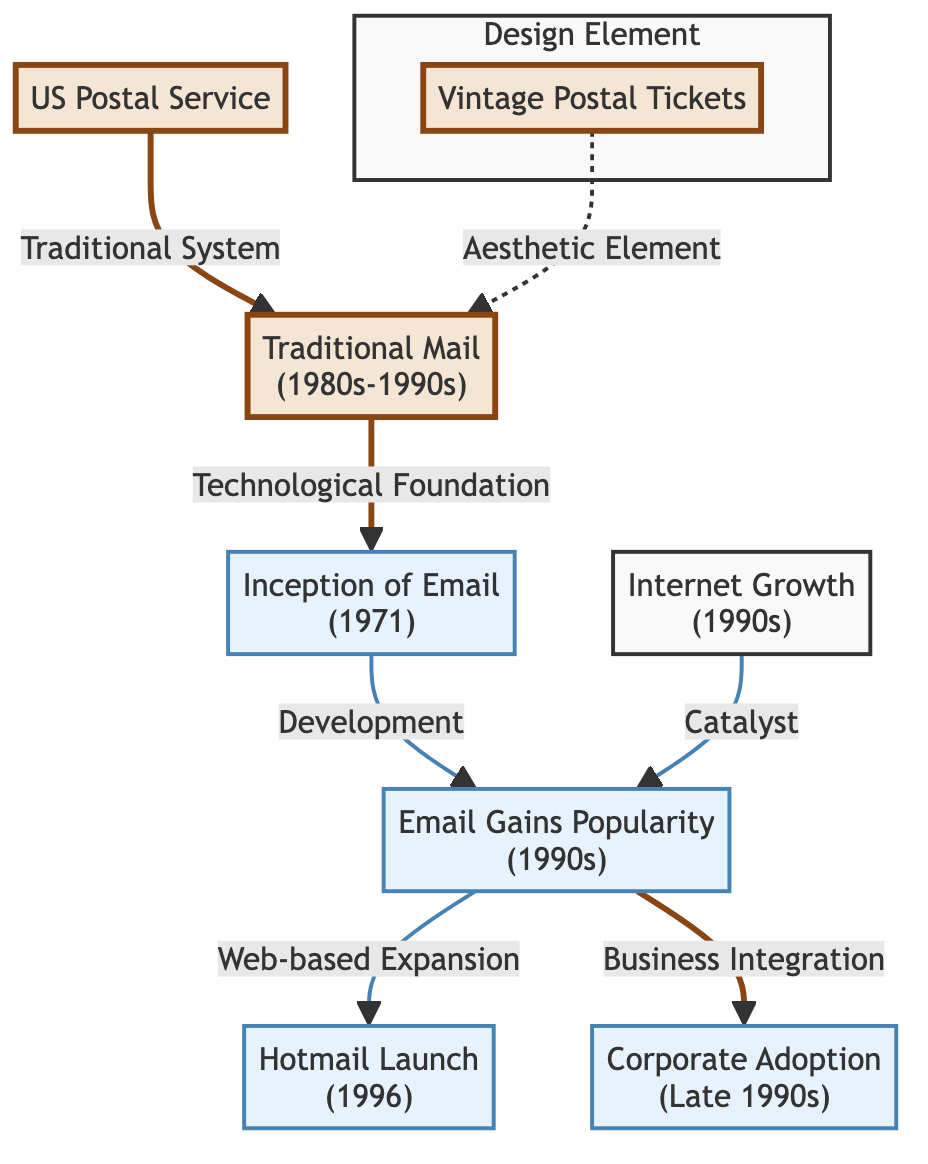What is the first event shown in the diagram? The first event is identified as "Inception of Email" which occurred in 1971. It is the starting point of the sequence related to email, linking it to traditional mail.
Answer: Inception of Email (1971) How many main events are depicted in the diagram? The main events represented in the diagram include: "Traditional Mail," "Inception of Email," "Email Gains Popularity," "Hotmail Launch," and "Corporate Adoption." Thus, there are five main events.
Answer: 5 What is the relationship between "Email Gains Popularity" and "Corporate Adoption"? The relationship is that "Email Gains Popularity" serves as a precursor to "Corporate Adoption." As email gains more usage and recognition, it leads to its adoption in the corporate sector, particularly toward the late 1990s.
Answer: Precursor Which aesthetic element is connected to "Traditional Mail"? The aesthetic element is "Vintage Postal Tickets," which is connected to "Traditional Mail" through the design influence represented by lines in the diagram.
Answer: Vintage Postal Tickets What major technological factor led to the popularity of email in the 1990s? The major technological factor is "Internet Growth," which is shown as a catalyst leading to the rising popularity of email during that decade.
Answer: Internet Growth Which email service was launched in 1996 according to the diagram? The email service launched in 1996 according to the diagram is "Hotmail." It is noted as a significant milestone in the web-based expansion of email usage.
Answer: Hotmail What does the arrow pointing from "Internet Growth" to "Email Gains Popularity" signify? The arrow signifies that "Internet Growth" acts as a catalyst that directly contributes to the increase in popularity of email during the 1990s.
Answer: Catalyst What type of design inspiration is related to "Traditional Mail"? The type of design inspiration related to "Traditional Mail" is derived from "Vintage Postal Tickets," indicating an aesthetic relevance that influences the representation of traditional mail in the diagram.
Answer: Vintage Postal Tickets 